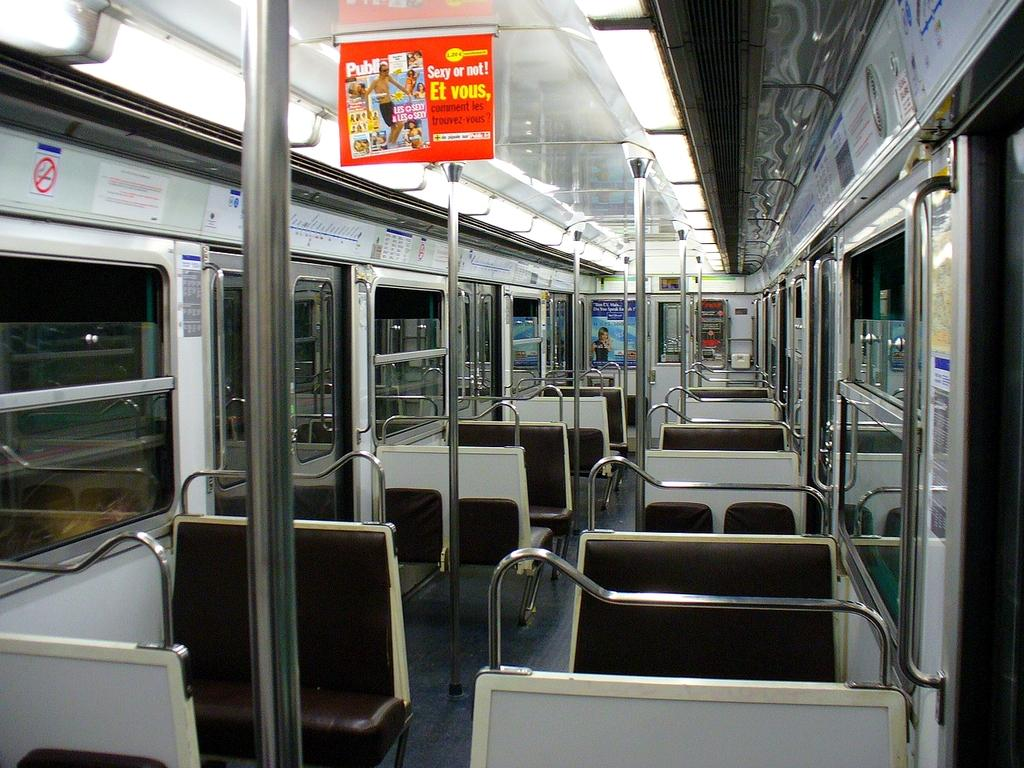Provide a one-sentence caption for the provided image. Bus with a sign on top that says "Sexy or not!". 